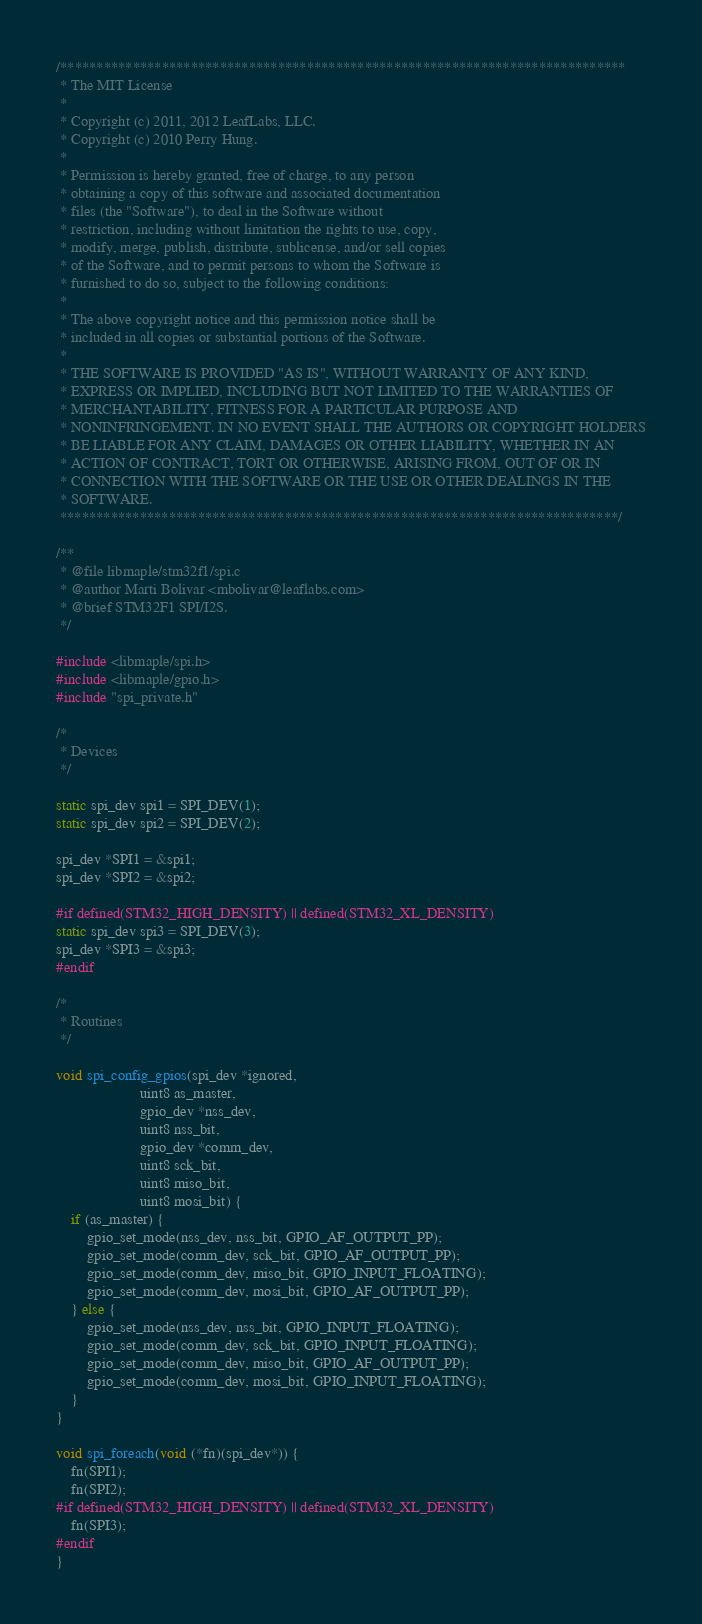Convert code to text. <code><loc_0><loc_0><loc_500><loc_500><_C_>/******************************************************************************
 * The MIT License
 *
 * Copyright (c) 2011, 2012 LeafLabs, LLC.
 * Copyright (c) 2010 Perry Hung.
 *
 * Permission is hereby granted, free of charge, to any person
 * obtaining a copy of this software and associated documentation
 * files (the "Software"), to deal in the Software without
 * restriction, including without limitation the rights to use, copy,
 * modify, merge, publish, distribute, sublicense, and/or sell copies
 * of the Software, and to permit persons to whom the Software is
 * furnished to do so, subject to the following conditions:
 *
 * The above copyright notice and this permission notice shall be
 * included in all copies or substantial portions of the Software.
 *
 * THE SOFTWARE IS PROVIDED "AS IS", WITHOUT WARRANTY OF ANY KIND,
 * EXPRESS OR IMPLIED, INCLUDING BUT NOT LIMITED TO THE WARRANTIES OF
 * MERCHANTABILITY, FITNESS FOR A PARTICULAR PURPOSE AND
 * NONINFRINGEMENT. IN NO EVENT SHALL THE AUTHORS OR COPYRIGHT HOLDERS
 * BE LIABLE FOR ANY CLAIM, DAMAGES OR OTHER LIABILITY, WHETHER IN AN
 * ACTION OF CONTRACT, TORT OR OTHERWISE, ARISING FROM, OUT OF OR IN
 * CONNECTION WITH THE SOFTWARE OR THE USE OR OTHER DEALINGS IN THE
 * SOFTWARE.
 *****************************************************************************/

/**
 * @file libmaple/stm32f1/spi.c
 * @author Marti Bolivar <mbolivar@leaflabs.com>
 * @brief STM32F1 SPI/I2S.
 */

#include <libmaple/spi.h>
#include <libmaple/gpio.h>
#include "spi_private.h"

/*
 * Devices
 */

static spi_dev spi1 = SPI_DEV(1);
static spi_dev spi2 = SPI_DEV(2);

spi_dev *SPI1 = &spi1;
spi_dev *SPI2 = &spi2;

#if defined(STM32_HIGH_DENSITY) || defined(STM32_XL_DENSITY)
static spi_dev spi3 = SPI_DEV(3);
spi_dev *SPI3 = &spi3;
#endif

/*
 * Routines
 */

void spi_config_gpios(spi_dev *ignored,
                      uint8 as_master,
                      gpio_dev *nss_dev,
                      uint8 nss_bit,
                      gpio_dev *comm_dev,
                      uint8 sck_bit,
                      uint8 miso_bit,
                      uint8 mosi_bit) {
    if (as_master) {
        gpio_set_mode(nss_dev, nss_bit, GPIO_AF_OUTPUT_PP);
        gpio_set_mode(comm_dev, sck_bit, GPIO_AF_OUTPUT_PP);
        gpio_set_mode(comm_dev, miso_bit, GPIO_INPUT_FLOATING);
        gpio_set_mode(comm_dev, mosi_bit, GPIO_AF_OUTPUT_PP);
    } else {
        gpio_set_mode(nss_dev, nss_bit, GPIO_INPUT_FLOATING);
        gpio_set_mode(comm_dev, sck_bit, GPIO_INPUT_FLOATING);
        gpio_set_mode(comm_dev, miso_bit, GPIO_AF_OUTPUT_PP);
        gpio_set_mode(comm_dev, mosi_bit, GPIO_INPUT_FLOATING);
    }
}

void spi_foreach(void (*fn)(spi_dev*)) {
    fn(SPI1);
    fn(SPI2);
#if defined(STM32_HIGH_DENSITY) || defined(STM32_XL_DENSITY)
    fn(SPI3);
#endif
}
</code> 